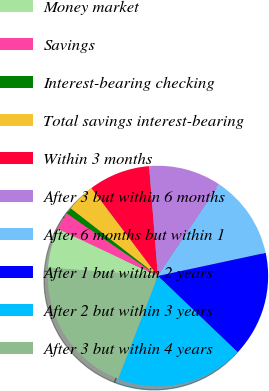Convert chart. <chart><loc_0><loc_0><loc_500><loc_500><pie_chart><fcel>Money market<fcel>Savings<fcel>Interest-bearing checking<fcel>Total savings interest-bearing<fcel>Within 3 months<fcel>After 3 but within 6 months<fcel>After 6 months but within 1<fcel>After 1 but within 2 years<fcel>After 2 but within 3 years<fcel>After 3 but within 4 years<nl><fcel>5.8%<fcel>2.56%<fcel>0.94%<fcel>4.18%<fcel>9.03%<fcel>10.65%<fcel>12.26%<fcel>15.5%<fcel>18.73%<fcel>20.35%<nl></chart> 